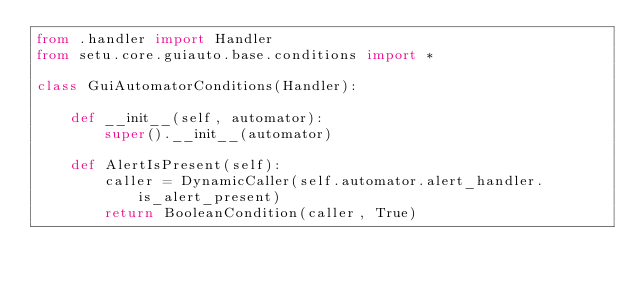Convert code to text. <code><loc_0><loc_0><loc_500><loc_500><_Python_>from .handler import Handler
from setu.core.guiauto.base.conditions import *

class GuiAutomatorConditions(Handler):

    def __init__(self, automator):
        super().__init__(automator)

    def AlertIsPresent(self):
        caller = DynamicCaller(self.automator.alert_handler.is_alert_present)
        return BooleanCondition(caller, True)</code> 